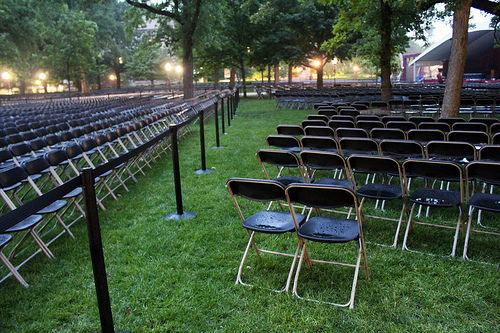<image>
Is there a chair under the chair? No. The chair is not positioned under the chair. The vertical relationship between these objects is different. 